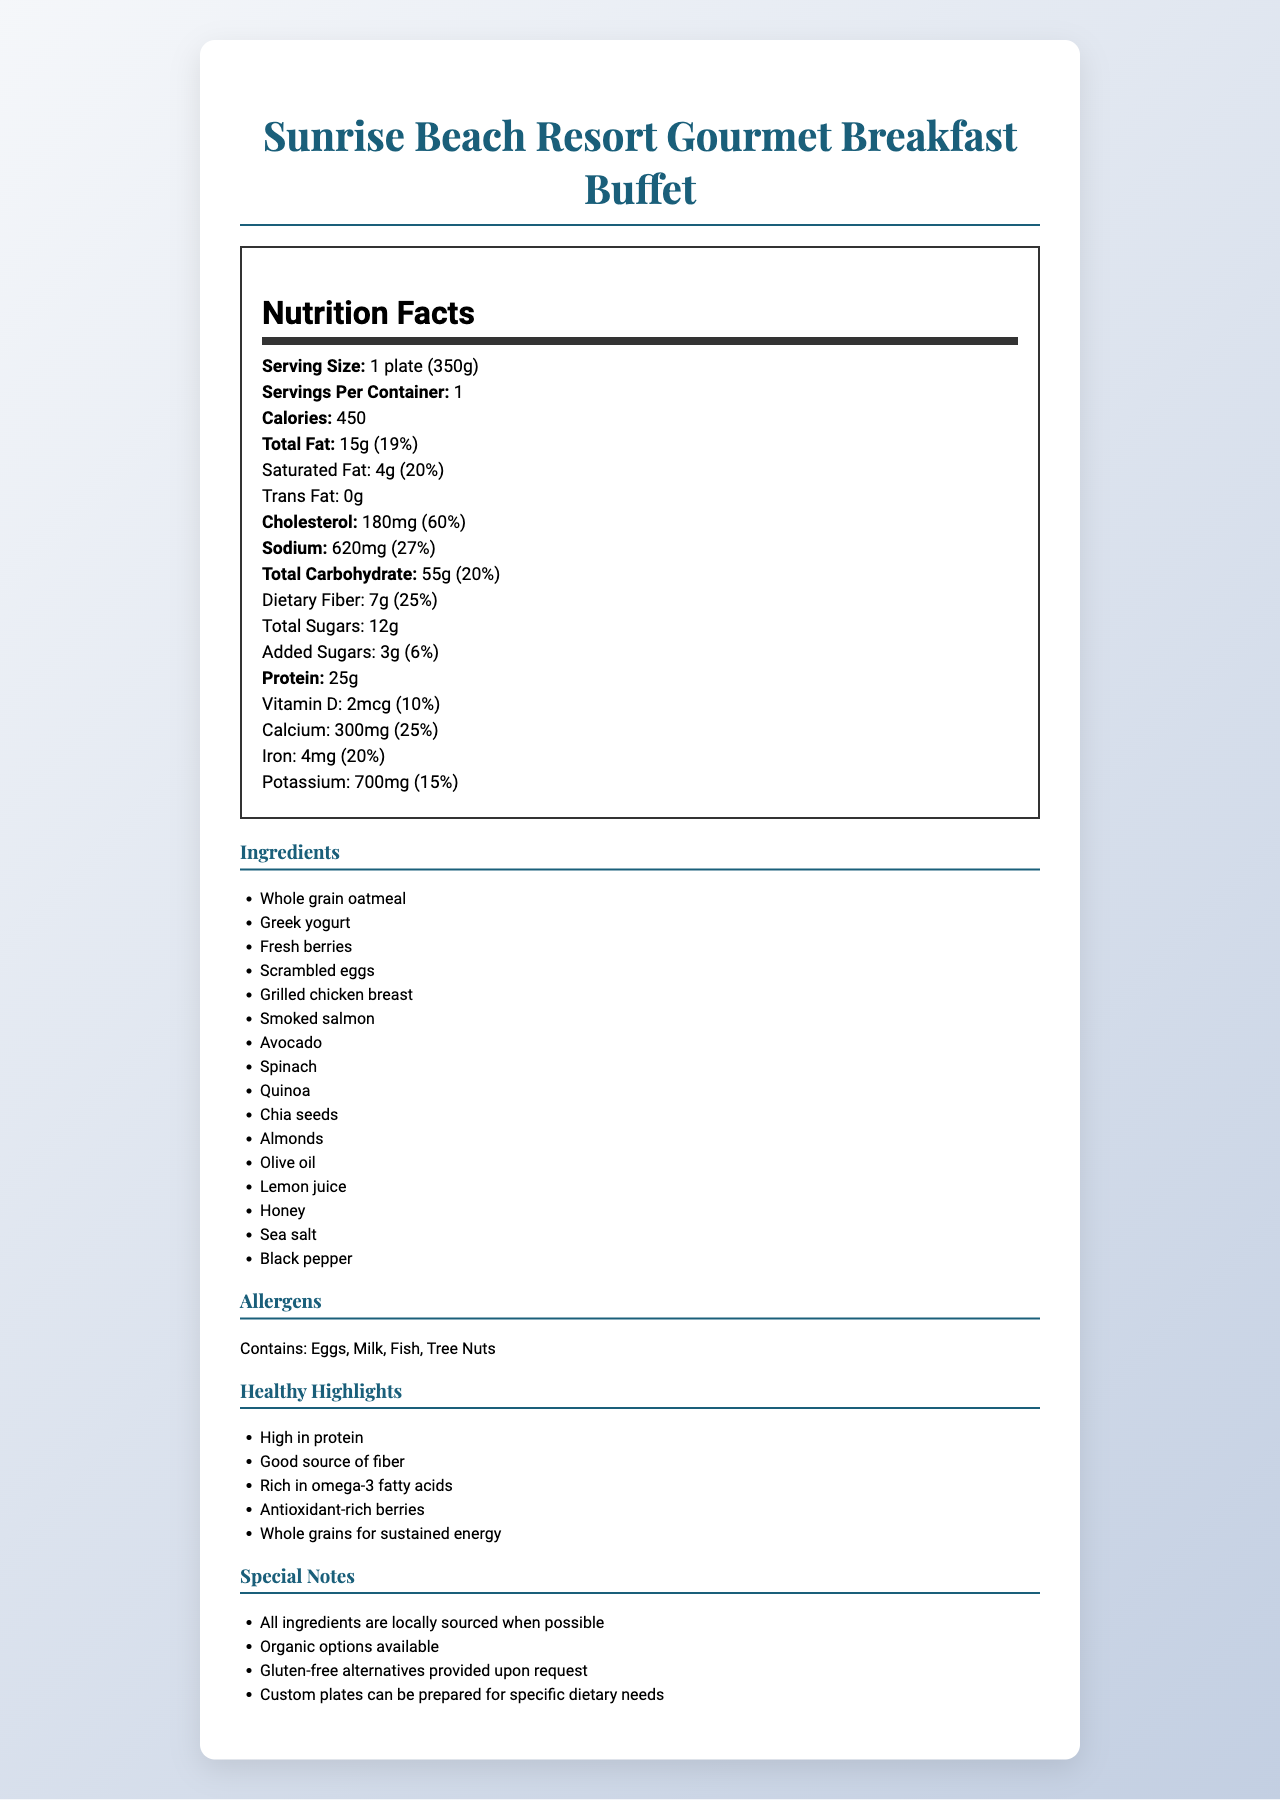what is the serving size? The serving size is stated as "1 plate (350g)" in the Nutrition Facts section.
Answer: 1 plate (350g) how many calories are in one serving? The calories per serving are listed as 450 in the Nutrition Facts section.
Answer: 450 how much protein does one serving provide? The amount of protein per serving is listed as 25g in the Nutrition Facts section.
Answer: 25g list two ingredients used in the breakfast buffet The ingredients section lists "Whole grain oatmeal" and "Greek yogurt" among others.
Answer: Whole grain oatmeal, Greek yogurt which allergens are contained in the breakfast buffet? The allergens section mentions "Contains: Eggs, Milk, Fish, Tree Nuts".
Answer: Eggs, Milk, Fish, Tree Nuts what amount of dietary fiber is present in one serving? The dietary fiber content is listed as 7g in the Nutrition Facts section.
Answer: 7g what is the daily value percentage of calcium provided? The daily value percentage of calcium is listed as 25% in the Nutrition Facts section.
Answer: 25% is there any trans fat in the breakfast buffet? The trans fat content is indicated as "0g" in the Nutrition Facts section, which means there is no trans fat.
Answer: No what healthy highlights are mentioned? The section under "Healthy Highlights" lists these specific points.
Answer: High in protein, Good source of fiber, Rich in omega-3 fatty acids, Antioxidant-rich berries, Whole grains for sustained energy which nutrient has the highest daily value percentage? A. Vitamin D B. Cholesterol C. Sodium D. Dietary Fiber Cholesterol has a daily value percentage of 60%, which is the highest compared to others listed.
Answer: B. Cholesterol how many grams of total sugar are in one serving? A. 3g B. 12g C. 7g The amount of total sugars in one serving is listed as 12g.
Answer: B. 12g are gluten-free alternatives available? It is mentioned under "Special Notes" that gluten-free alternatives are provided upon request.
Answer: Yes summarize the main idea of the document The main idea of the document is to provide a detailed nutritional breakdown of the breakfast buffet, along with information on ingredients, allergens, health benefits, and special dietary options available.
Answer: The document presents the nutrition facts for the "Sunrise Beach Resort Gourmet Breakfast Buffet". It includes nutritional details like serving size, calories, fat, cholesterol, sodium, carbohydrates, fiber, sugars, protein, vitamins, and minerals. Additionally, it lists ingredients, allergens, healthy highlights, and special notes about the buffet. what is the sodium content in milligrams for one serving? The sodium content is listed as 620mg in the Nutrition Facts section.
Answer: 620mg can you determine the price of the breakfast buffet from the document? The document does not provide any information about the price of the breakfast buffet.
Answer: Cannot be determined 